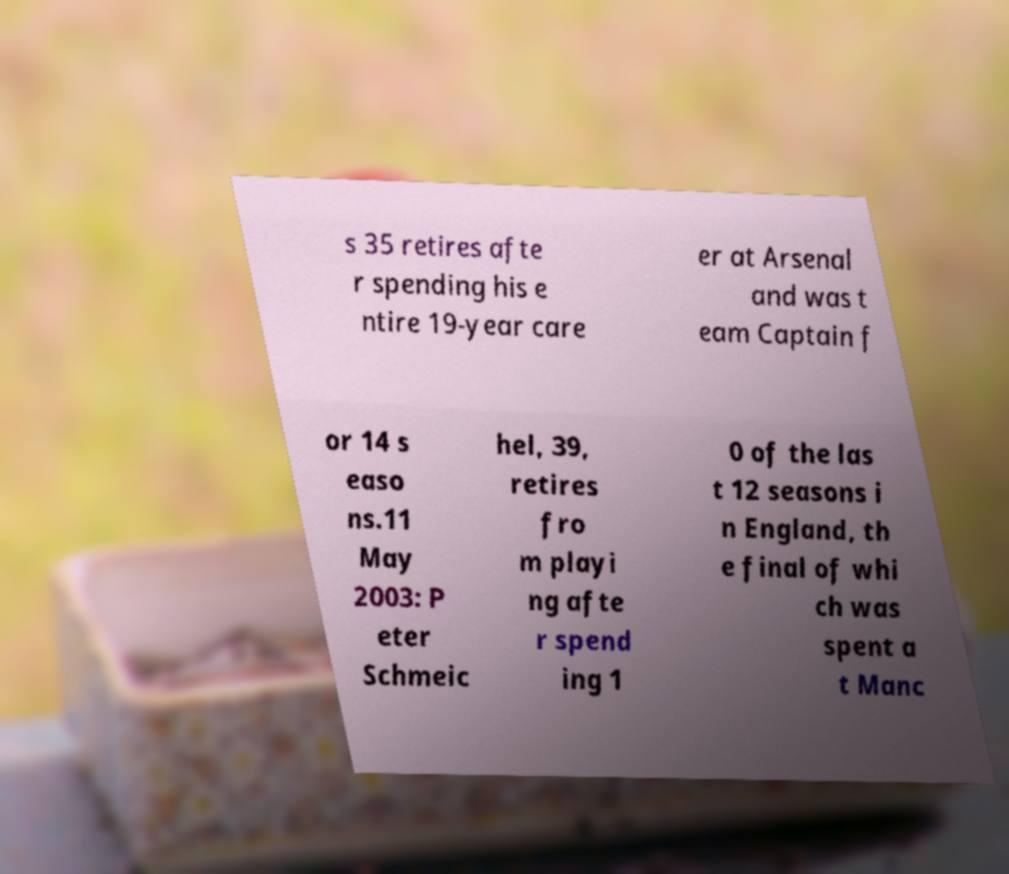I need the written content from this picture converted into text. Can you do that? s 35 retires afte r spending his e ntire 19-year care er at Arsenal and was t eam Captain f or 14 s easo ns.11 May 2003: P eter Schmeic hel, 39, retires fro m playi ng afte r spend ing 1 0 of the las t 12 seasons i n England, th e final of whi ch was spent a t Manc 